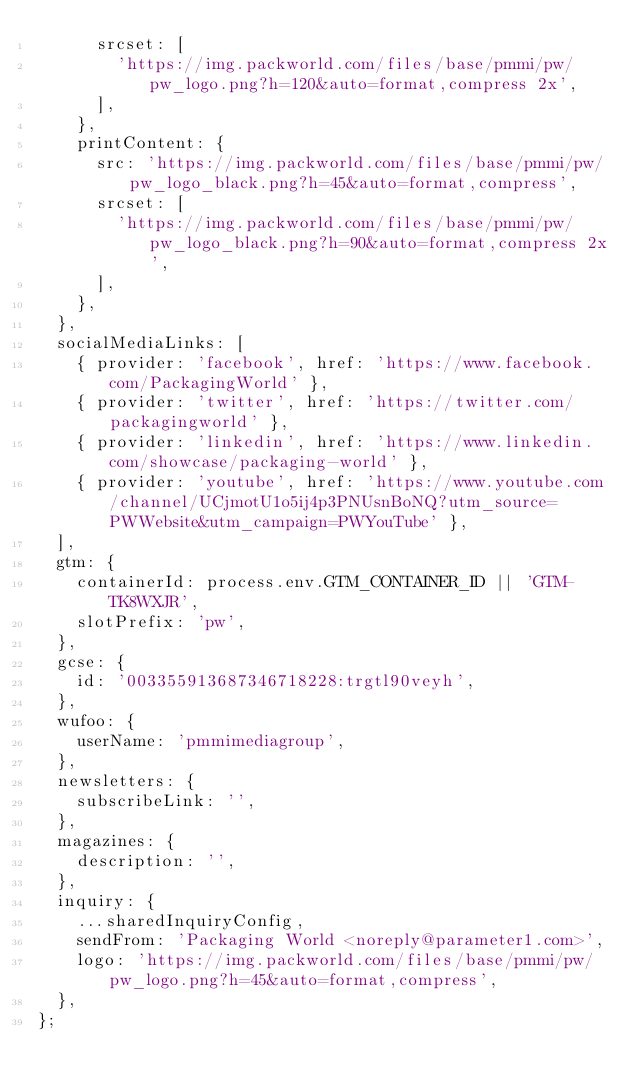<code> <loc_0><loc_0><loc_500><loc_500><_JavaScript_>      srcset: [
        'https://img.packworld.com/files/base/pmmi/pw/pw_logo.png?h=120&auto=format,compress 2x',
      ],
    },
    printContent: {
      src: 'https://img.packworld.com/files/base/pmmi/pw/pw_logo_black.png?h=45&auto=format,compress',
      srcset: [
        'https://img.packworld.com/files/base/pmmi/pw/pw_logo_black.png?h=90&auto=format,compress 2x',
      ],
    },
  },
  socialMediaLinks: [
    { provider: 'facebook', href: 'https://www.facebook.com/PackagingWorld' },
    { provider: 'twitter', href: 'https://twitter.com/packagingworld' },
    { provider: 'linkedin', href: 'https://www.linkedin.com/showcase/packaging-world' },
    { provider: 'youtube', href: 'https://www.youtube.com/channel/UCjmotU1o5ij4p3PNUsnBoNQ?utm_source=PWWebsite&utm_campaign=PWYouTube' },
  ],
  gtm: {
    containerId: process.env.GTM_CONTAINER_ID || 'GTM-TK8WXJR',
    slotPrefix: 'pw',
  },
  gcse: {
    id: '003355913687346718228:trgtl90veyh',
  },
  wufoo: {
    userName: 'pmmimediagroup',
  },
  newsletters: {
    subscribeLink: '',
  },
  magazines: {
    description: '',
  },
  inquiry: {
    ...sharedInquiryConfig,
    sendFrom: 'Packaging World <noreply@parameter1.com>',
    logo: 'https://img.packworld.com/files/base/pmmi/pw/pw_logo.png?h=45&auto=format,compress',
  },
};
</code> 